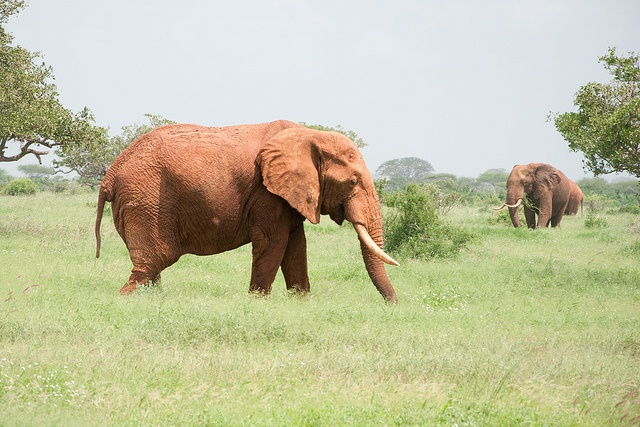Describe the objects in this image and their specific colors. I can see elephant in darkgray, maroon, salmon, black, and tan tones, elephant in darkgray, gray, and tan tones, and elephant in darkgray, gray, salmon, and tan tones in this image. 